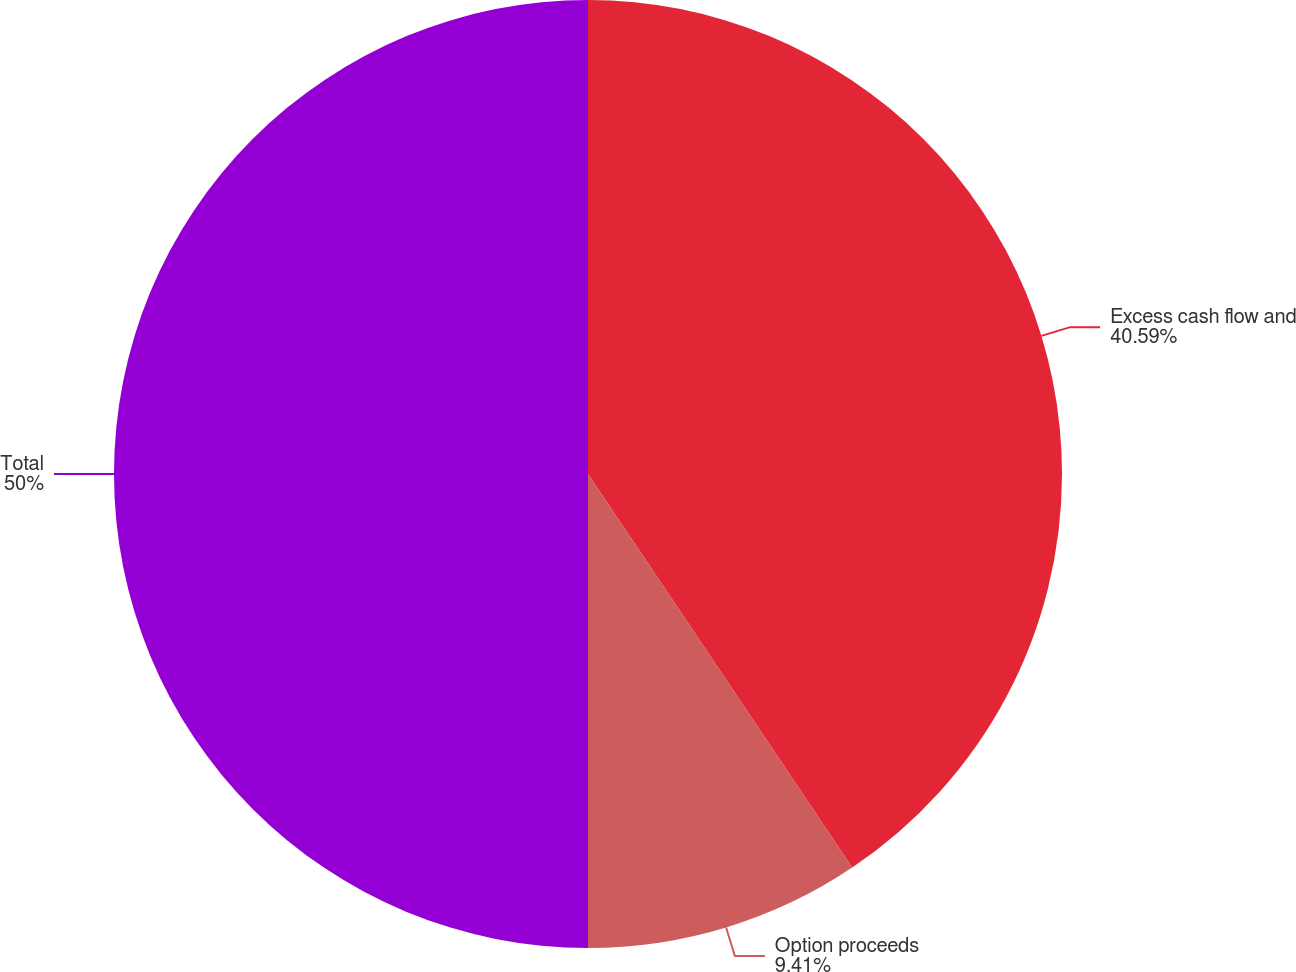Convert chart. <chart><loc_0><loc_0><loc_500><loc_500><pie_chart><fcel>Excess cash flow and<fcel>Option proceeds<fcel>Total<nl><fcel>40.59%<fcel>9.41%<fcel>50.0%<nl></chart> 